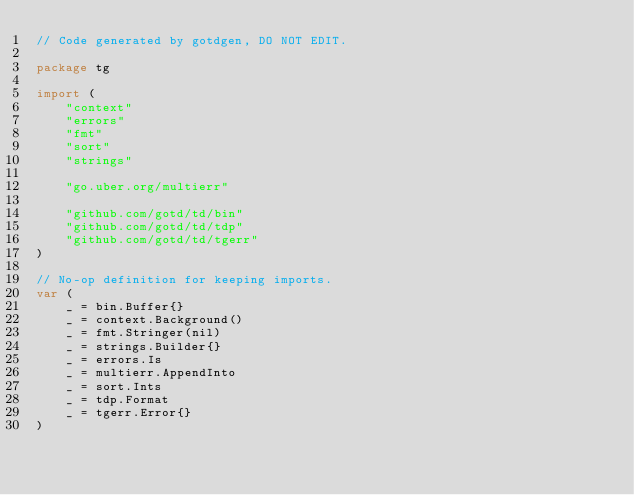<code> <loc_0><loc_0><loc_500><loc_500><_Go_>// Code generated by gotdgen, DO NOT EDIT.

package tg

import (
	"context"
	"errors"
	"fmt"
	"sort"
	"strings"

	"go.uber.org/multierr"

	"github.com/gotd/td/bin"
	"github.com/gotd/td/tdp"
	"github.com/gotd/td/tgerr"
)

// No-op definition for keeping imports.
var (
	_ = bin.Buffer{}
	_ = context.Background()
	_ = fmt.Stringer(nil)
	_ = strings.Builder{}
	_ = errors.Is
	_ = multierr.AppendInto
	_ = sort.Ints
	_ = tdp.Format
	_ = tgerr.Error{}
)
</code> 